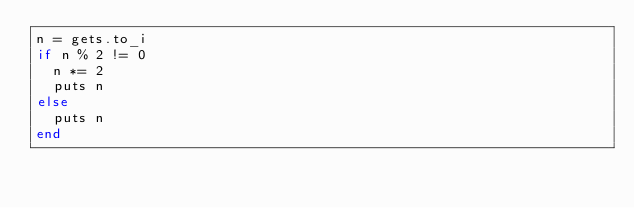Convert code to text. <code><loc_0><loc_0><loc_500><loc_500><_Ruby_>n = gets.to_i
if n % 2 != 0
  n *= 2
  puts n
else
  puts n
end
</code> 